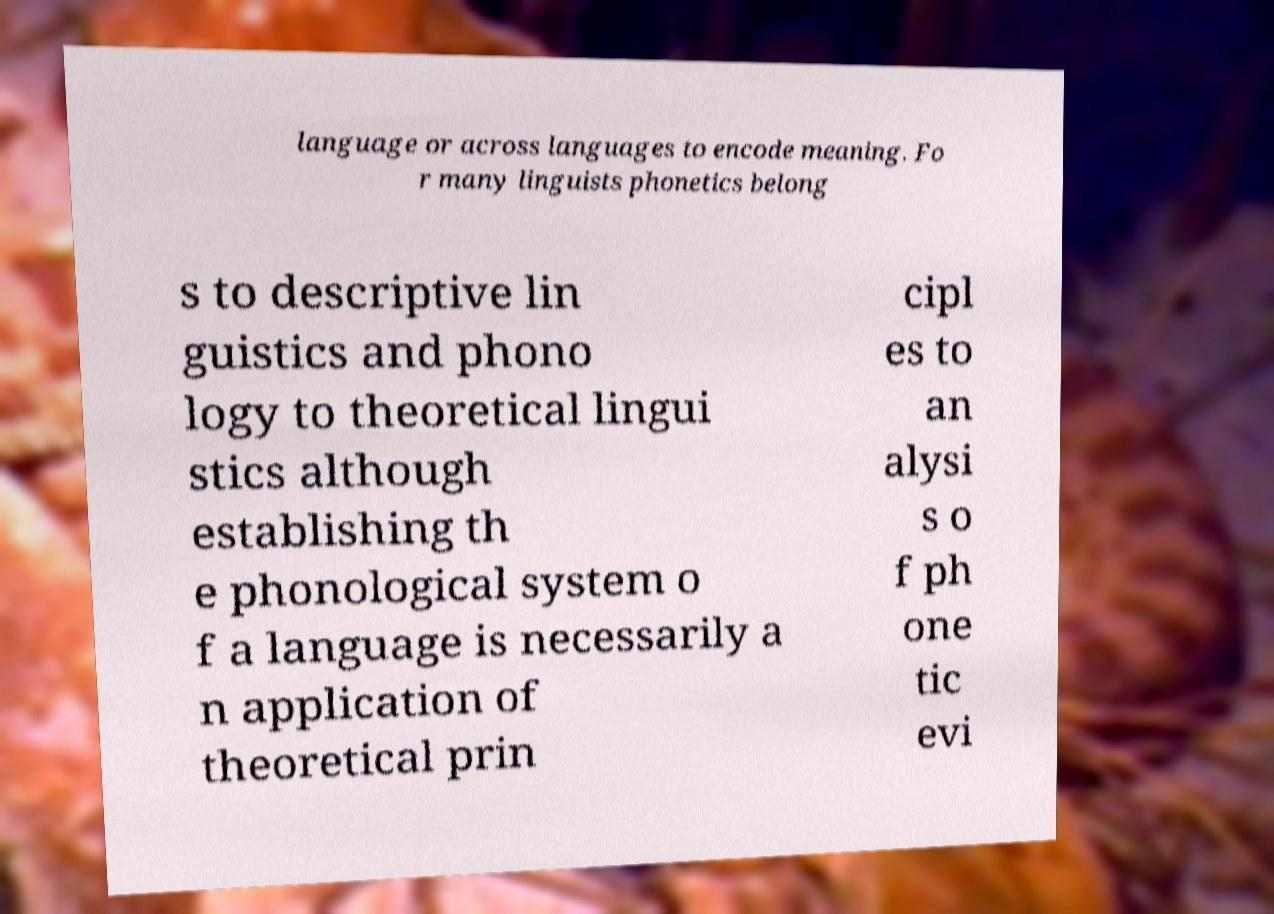Could you assist in decoding the text presented in this image and type it out clearly? language or across languages to encode meaning. Fo r many linguists phonetics belong s to descriptive lin guistics and phono logy to theoretical lingui stics although establishing th e phonological system o f a language is necessarily a n application of theoretical prin cipl es to an alysi s o f ph one tic evi 